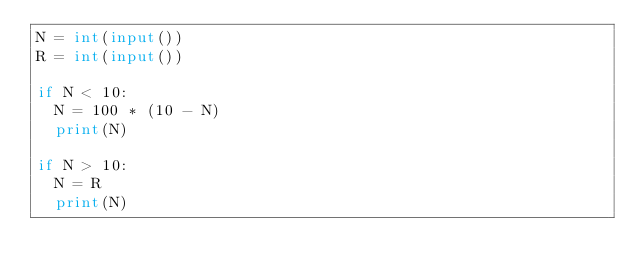Convert code to text. <code><loc_0><loc_0><loc_500><loc_500><_Python_>N = int(input())
R = int(input())

if N < 10:
  N = 100 * (10 - N) 
  print(N)
  
if N > 10:
  N = R
  print(N)
  </code> 